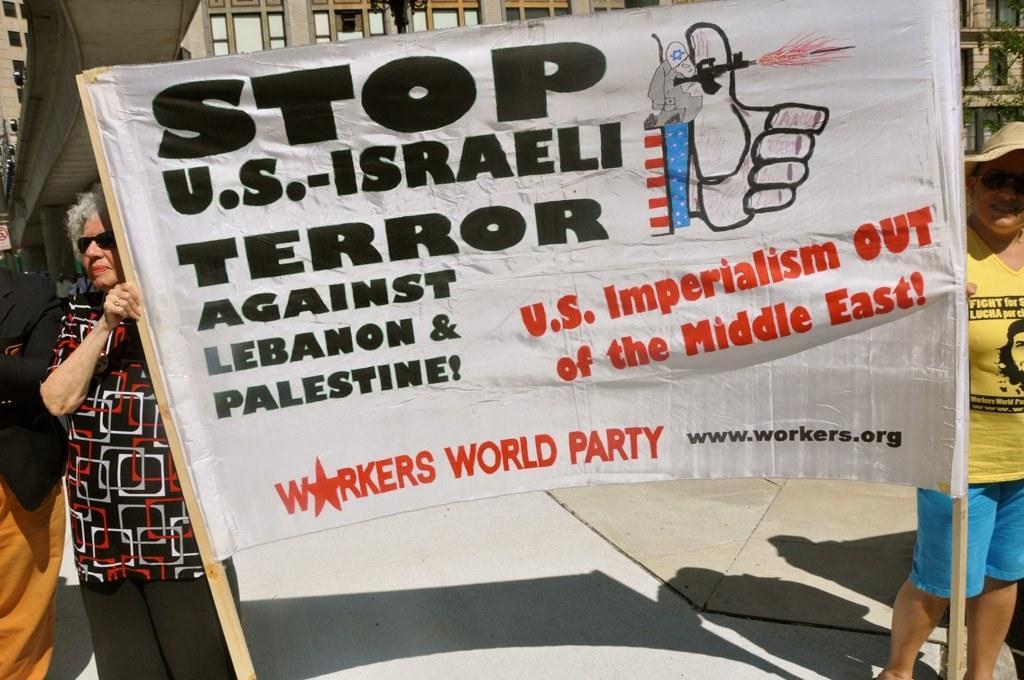Can you describe this image briefly? In this image I can see two persons are holding a banner in the hands. On the banner, I can see some text. On the left side there is another person standing. In the background there is a building. 